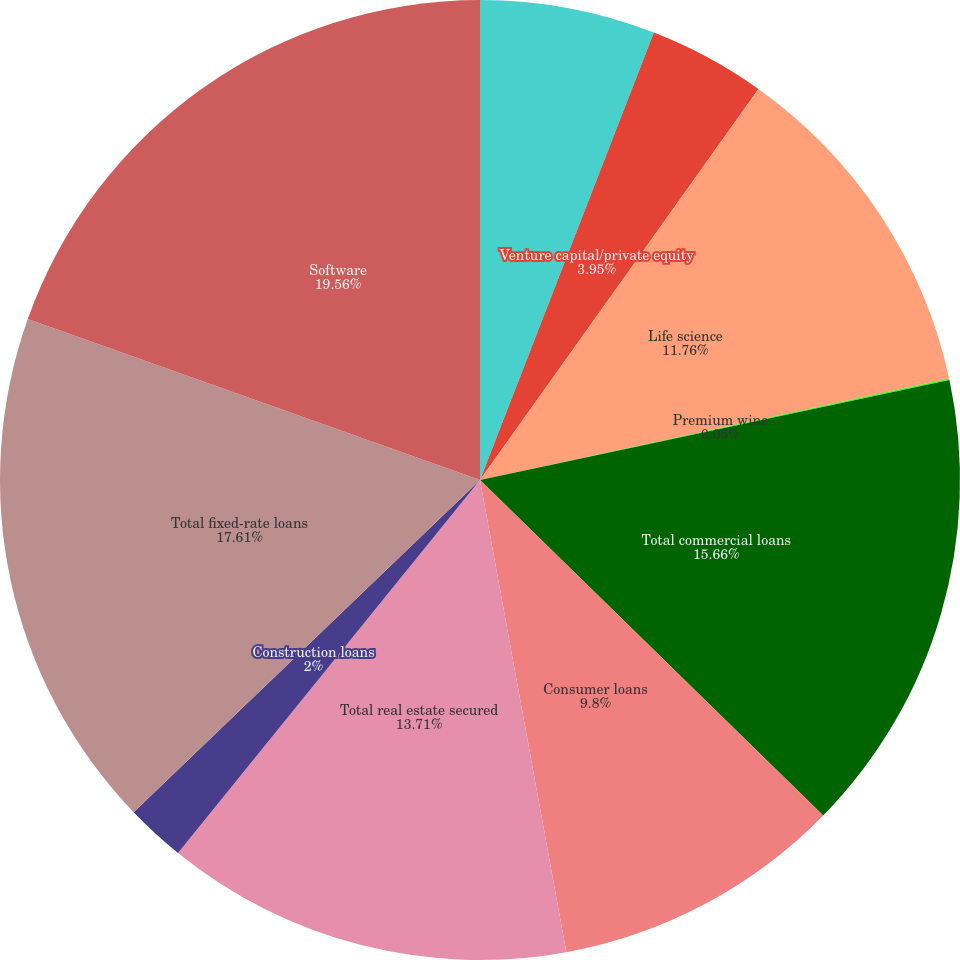<chart> <loc_0><loc_0><loc_500><loc_500><pie_chart><fcel>Hardware<fcel>Venture capital/private equity<fcel>Life science<fcel>Premium wine<fcel>Total commercial loans<fcel>Consumer loans<fcel>Total real estate secured<fcel>Construction loans<fcel>Total fixed-rate loans<fcel>Software<nl><fcel>5.9%<fcel>3.95%<fcel>11.76%<fcel>0.05%<fcel>15.66%<fcel>9.8%<fcel>13.71%<fcel>2.0%<fcel>17.61%<fcel>19.56%<nl></chart> 